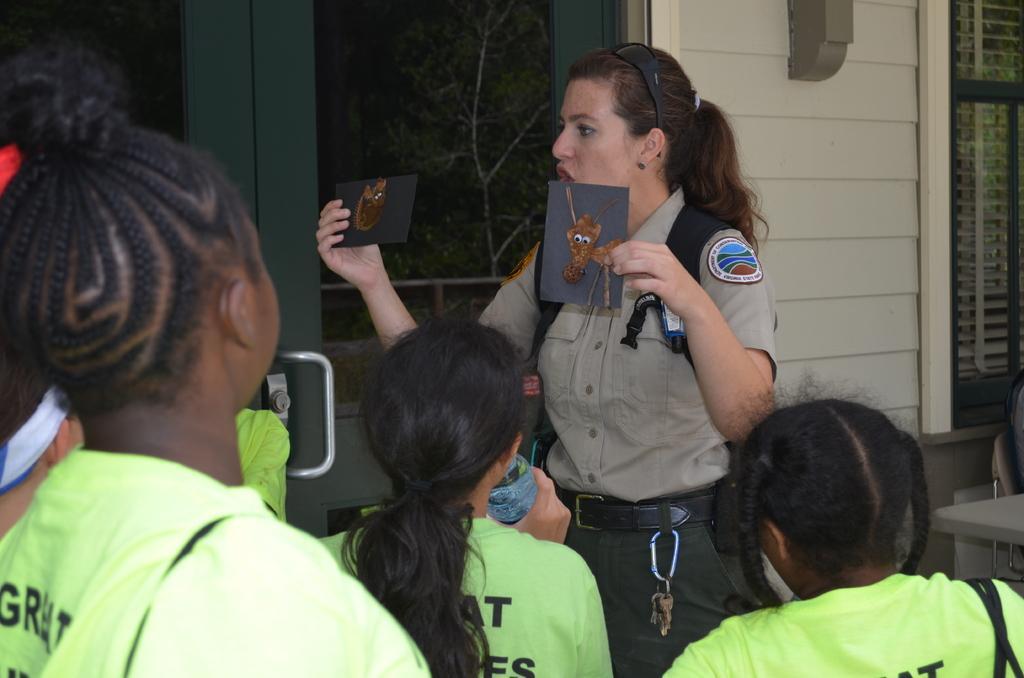Describe this image in one or two sentences. In this image I can see a person standing and holding some cards. Also there are few people standing. There is a wall with window and a glass door. Through the glass door I can see trees. 